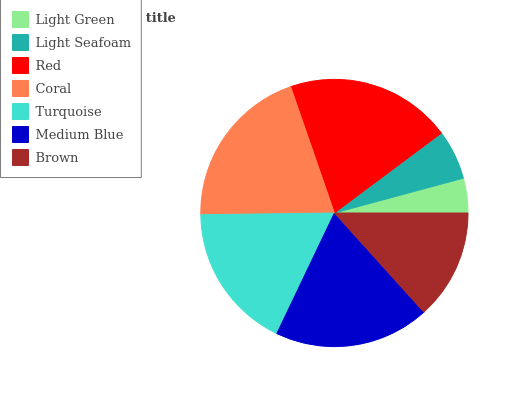Is Light Green the minimum?
Answer yes or no. Yes. Is Red the maximum?
Answer yes or no. Yes. Is Light Seafoam the minimum?
Answer yes or no. No. Is Light Seafoam the maximum?
Answer yes or no. No. Is Light Seafoam greater than Light Green?
Answer yes or no. Yes. Is Light Green less than Light Seafoam?
Answer yes or no. Yes. Is Light Green greater than Light Seafoam?
Answer yes or no. No. Is Light Seafoam less than Light Green?
Answer yes or no. No. Is Turquoise the high median?
Answer yes or no. Yes. Is Turquoise the low median?
Answer yes or no. Yes. Is Light Green the high median?
Answer yes or no. No. Is Red the low median?
Answer yes or no. No. 